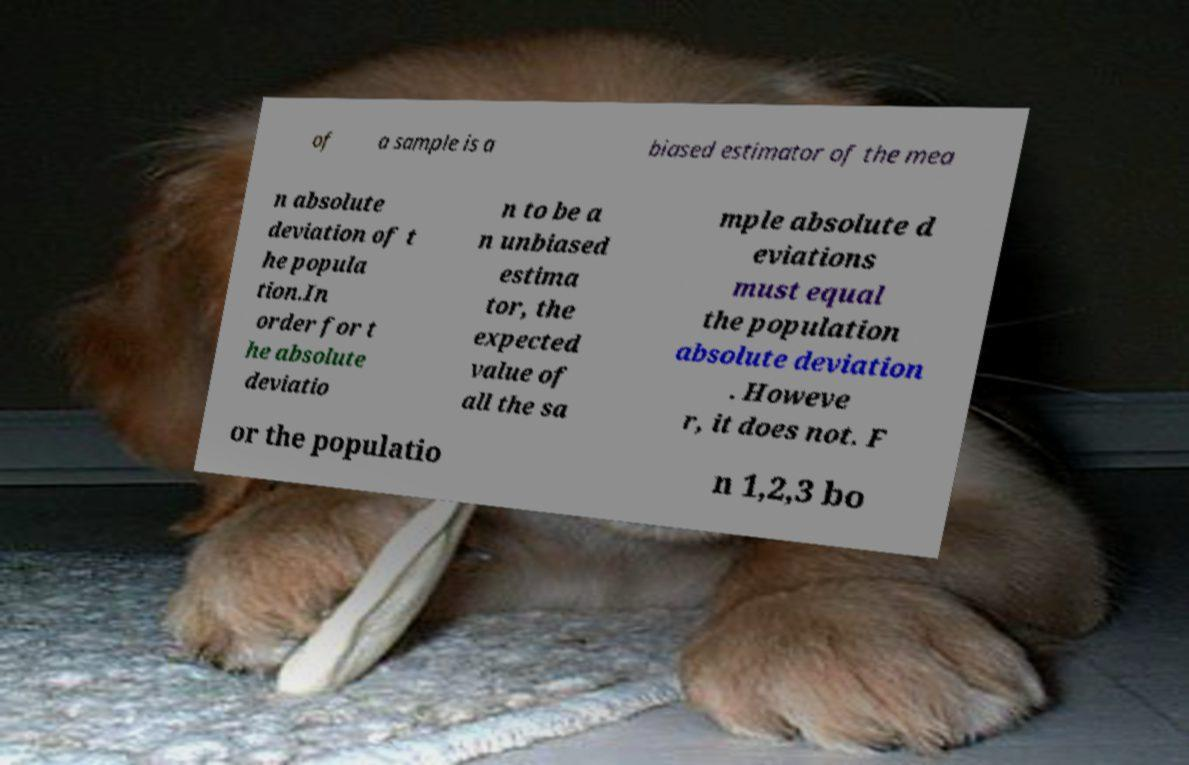Please read and relay the text visible in this image. What does it say? of a sample is a biased estimator of the mea n absolute deviation of t he popula tion.In order for t he absolute deviatio n to be a n unbiased estima tor, the expected value of all the sa mple absolute d eviations must equal the population absolute deviation . Howeve r, it does not. F or the populatio n 1,2,3 bo 